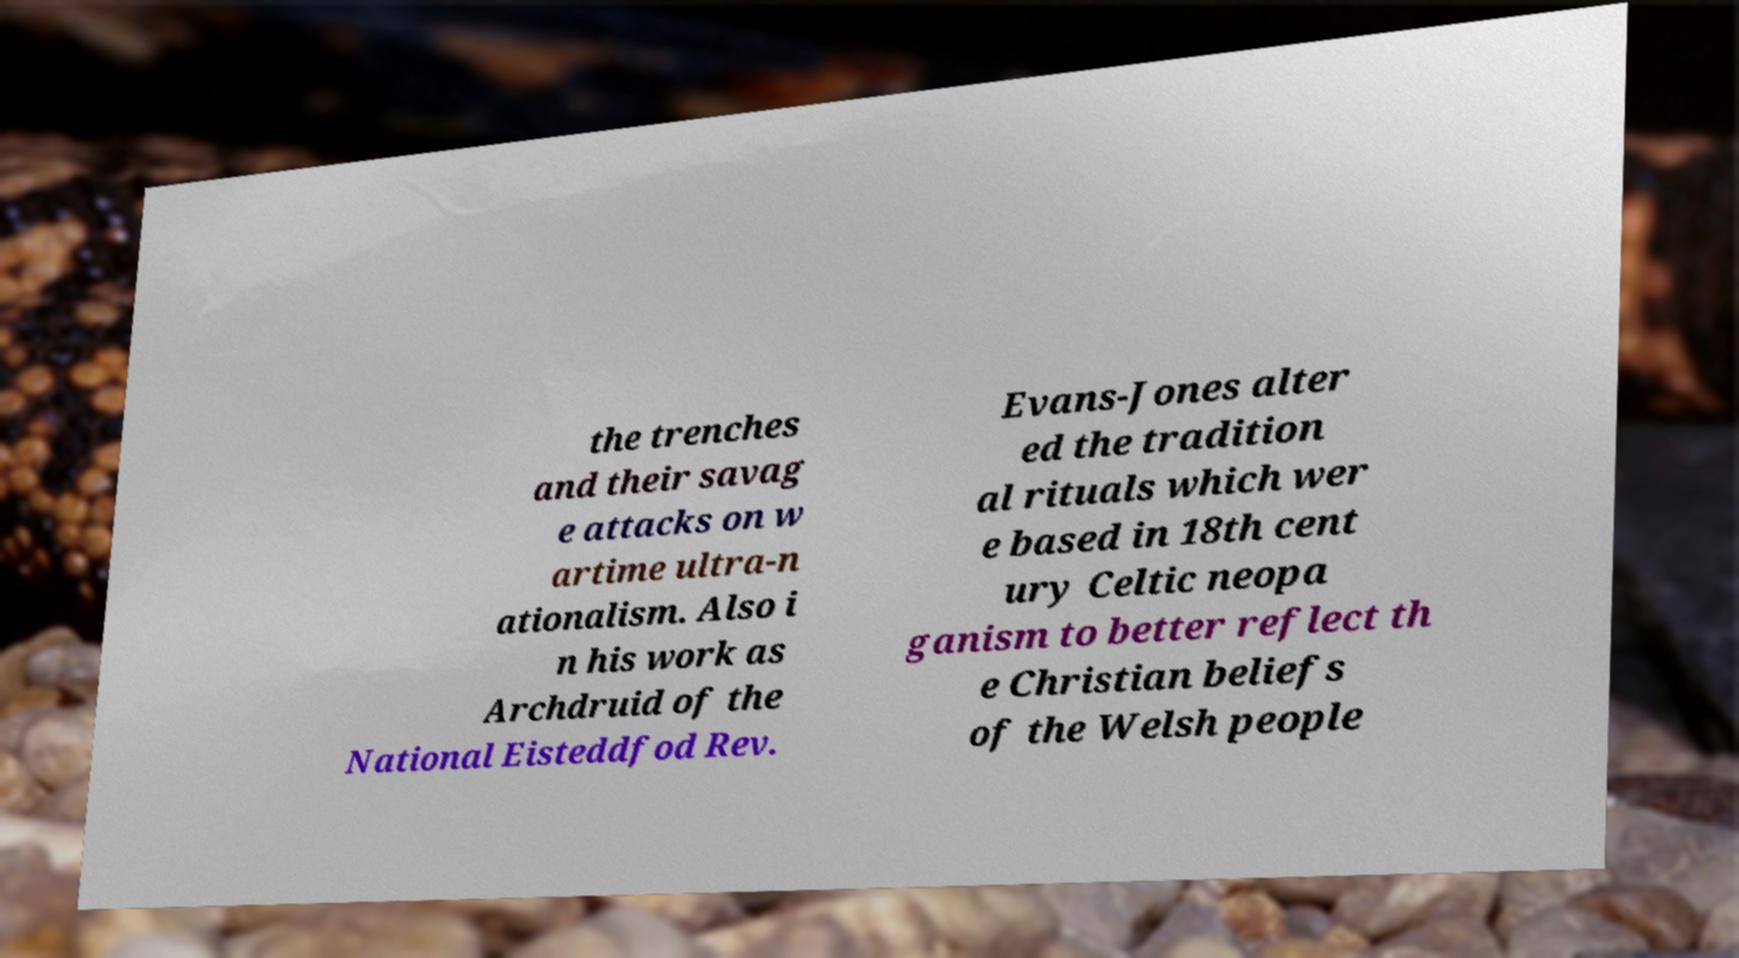What messages or text are displayed in this image? I need them in a readable, typed format. the trenches and their savag e attacks on w artime ultra-n ationalism. Also i n his work as Archdruid of the National Eisteddfod Rev. Evans-Jones alter ed the tradition al rituals which wer e based in 18th cent ury Celtic neopa ganism to better reflect th e Christian beliefs of the Welsh people 